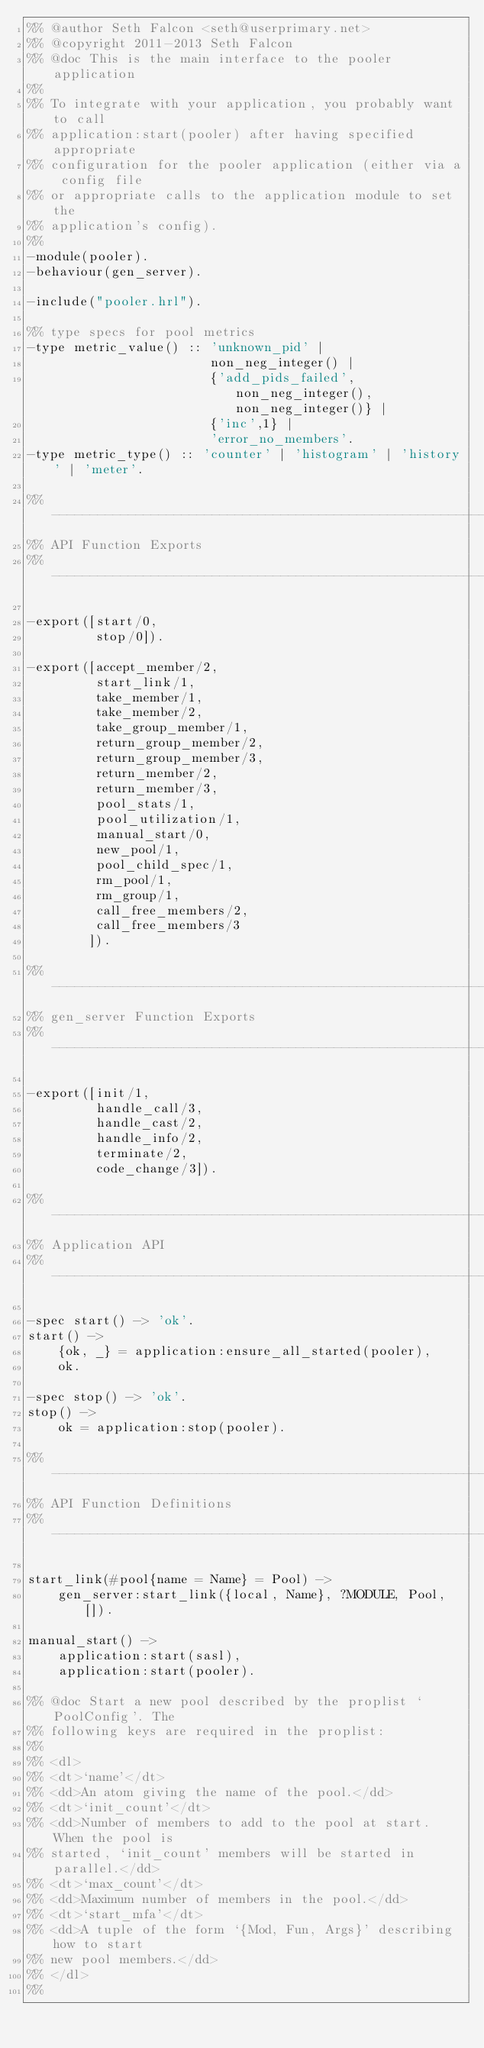Convert code to text. <code><loc_0><loc_0><loc_500><loc_500><_Erlang_>%% @author Seth Falcon <seth@userprimary.net>
%% @copyright 2011-2013 Seth Falcon
%% @doc This is the main interface to the pooler application
%%
%% To integrate with your application, you probably want to call
%% application:start(pooler) after having specified appropriate
%% configuration for the pooler application (either via a config file
%% or appropriate calls to the application module to set the
%% application's config).
%%
-module(pooler).
-behaviour(gen_server).

-include("pooler.hrl").

%% type specs for pool metrics
-type metric_value() :: 'unknown_pid' |
                        non_neg_integer() |
                        {'add_pids_failed', non_neg_integer(), non_neg_integer()} |
                        {'inc',1} |
                        'error_no_members'.
-type metric_type() :: 'counter' | 'histogram' | 'history' | 'meter'.

%% ------------------------------------------------------------------
%% API Function Exports
%% ------------------------------------------------------------------

-export([start/0,
         stop/0]).

-export([accept_member/2,
         start_link/1,
         take_member/1,
         take_member/2,
         take_group_member/1,
         return_group_member/2,
         return_group_member/3,
         return_member/2,
         return_member/3,
         pool_stats/1,
         pool_utilization/1,
         manual_start/0,
         new_pool/1,
         pool_child_spec/1,
         rm_pool/1,
         rm_group/1,
         call_free_members/2,
         call_free_members/3
        ]).

%% ------------------------------------------------------------------
%% gen_server Function Exports
%% ------------------------------------------------------------------

-export([init/1,
         handle_call/3,
         handle_cast/2,
         handle_info/2,
         terminate/2,
         code_change/3]).

%% ------------------------------------------------------------------
%% Application API
%% ------------------------------------------------------------------

-spec start() -> 'ok'.
start() ->
    {ok, _} = application:ensure_all_started(pooler),
    ok.

-spec stop() -> 'ok'.
stop() ->
    ok = application:stop(pooler).

%% ------------------------------------------------------------------
%% API Function Definitions
%% ------------------------------------------------------------------

start_link(#pool{name = Name} = Pool) ->
    gen_server:start_link({local, Name}, ?MODULE, Pool, []).

manual_start() ->
    application:start(sasl),
    application:start(pooler).

%% @doc Start a new pool described by the proplist `PoolConfig'. The
%% following keys are required in the proplist:
%%
%% <dl>
%% <dt>`name'</dt>
%% <dd>An atom giving the name of the pool.</dd>
%% <dt>`init_count'</dt>
%% <dd>Number of members to add to the pool at start. When the pool is
%% started, `init_count' members will be started in parallel.</dd>
%% <dt>`max_count'</dt>
%% <dd>Maximum number of members in the pool.</dd>
%% <dt>`start_mfa'</dt>
%% <dd>A tuple of the form `{Mod, Fun, Args}' describing how to start
%% new pool members.</dd>
%% </dl>
%%</code> 